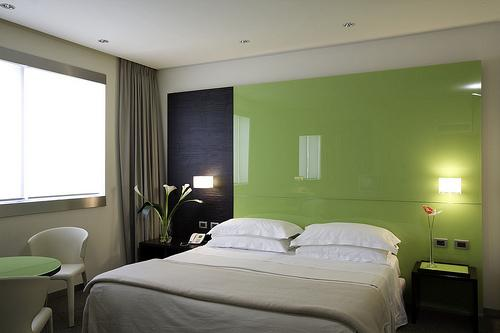Describe the position of the curtains and the color of the blanket on the bed in the image. The curtains are pulled back, and the blanket on the bed is beige. Mention any electronic gadgets present in the image and their location. A phone is located next to the bed on the night stand. Identify any floral elements present in the image. There are vases with red and white flowers, and one vase has long stemmed red flowers. What type of flowers are in the vases and where are they placed? There are lilies on the beside table, red and white flowers in a tall thin clear vase, and white flowers next to the bed. Describe the arrangement of chairs and table near the window. There are two white chairs by the green table, one located in front of it and the other beside it. Mention three main features of the bedroom in the image. A green wall behind the bed, a large window with beige curtains, and a green table accompanied by white chairs. Provide a brief summary of the scene captured in the image. The image shows a bedroom with a beige bed, green wall, large window, long beige curtains, green table, white chairs, vases with flowers, and night stands with a phone. List the furniture items present in the image along with their colors. There's a beige bed, green table with black edge, black end table, brown night stand, white chairs, and a black wood night stand. Describe the lighting fixtures in the image. There are lights in the ceiling and two rectangular white lights at opposite ends of the headboard wall. How many pillows are on the bed, and what color are they? There are four white pillows on the bed. 